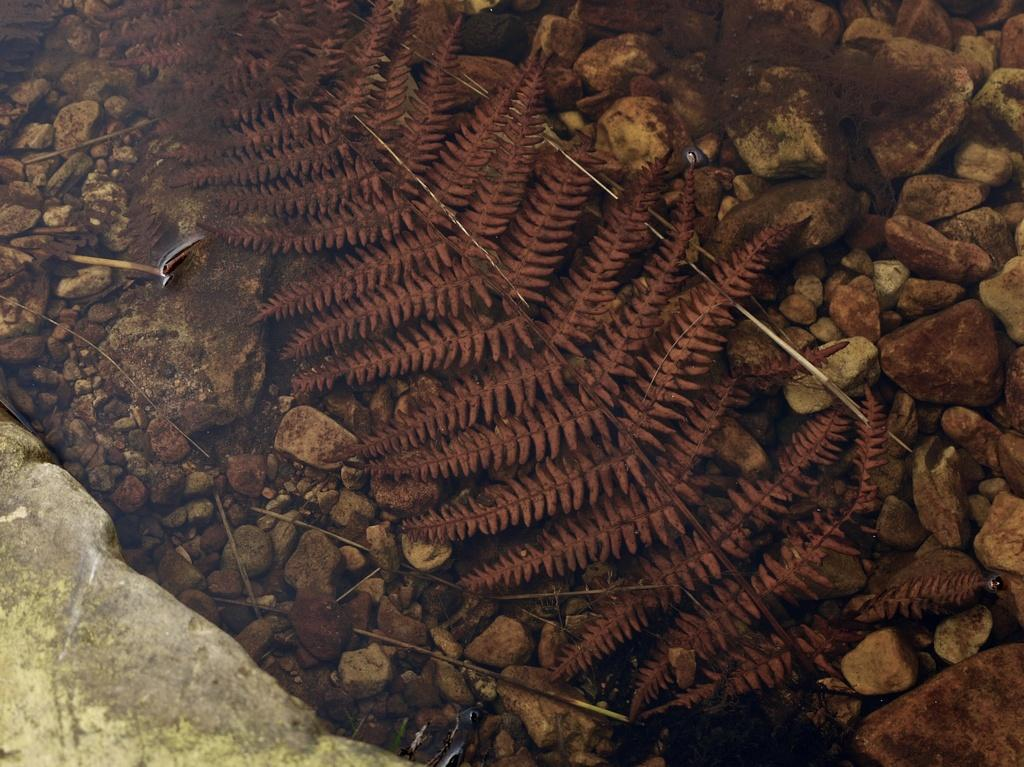What type of objects can be seen on the ground in the image? There are stones, leaves, and sticks on the ground. Can you describe the texture of the objects on the ground? The stones and sticks have a rough texture, while the leaves are smooth. What might be the purpose of the sticks in the image? The sticks could be used for various purposes, such as building a shelter or starting a fire. What type of potato is being used as a mailbox in the image? There is no potato or mailbox present in the image; it only features stones, leaves, and sticks on the ground. 